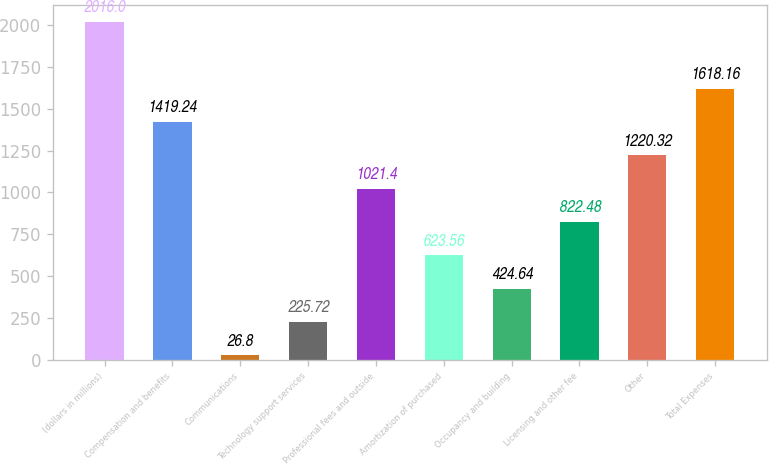<chart> <loc_0><loc_0><loc_500><loc_500><bar_chart><fcel>(dollars in millions)<fcel>Compensation and benefits<fcel>Communications<fcel>Technology support services<fcel>Professional fees and outside<fcel>Amortization of purchased<fcel>Occupancy and building<fcel>Licensing and other fee<fcel>Other<fcel>Total Expenses<nl><fcel>2016<fcel>1419.24<fcel>26.8<fcel>225.72<fcel>1021.4<fcel>623.56<fcel>424.64<fcel>822.48<fcel>1220.32<fcel>1618.16<nl></chart> 